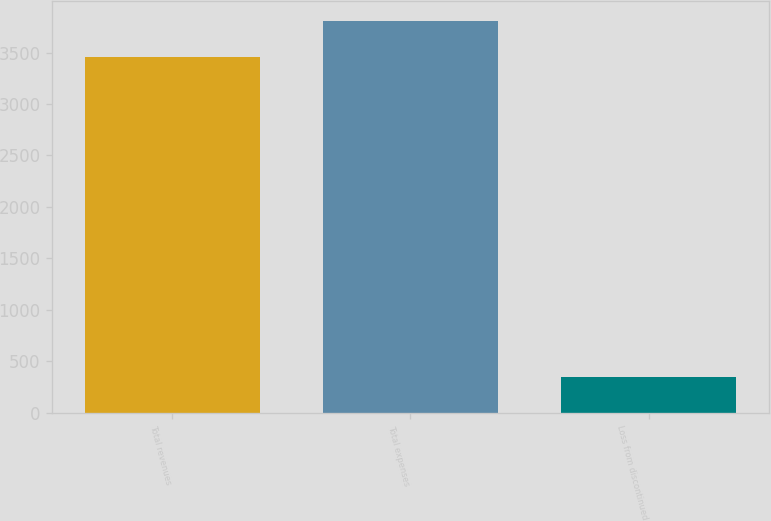<chart> <loc_0><loc_0><loc_500><loc_500><bar_chart><fcel>Total revenues<fcel>Total expenses<fcel>Loss from discontinued<nl><fcel>3458<fcel>3806<fcel>348<nl></chart> 